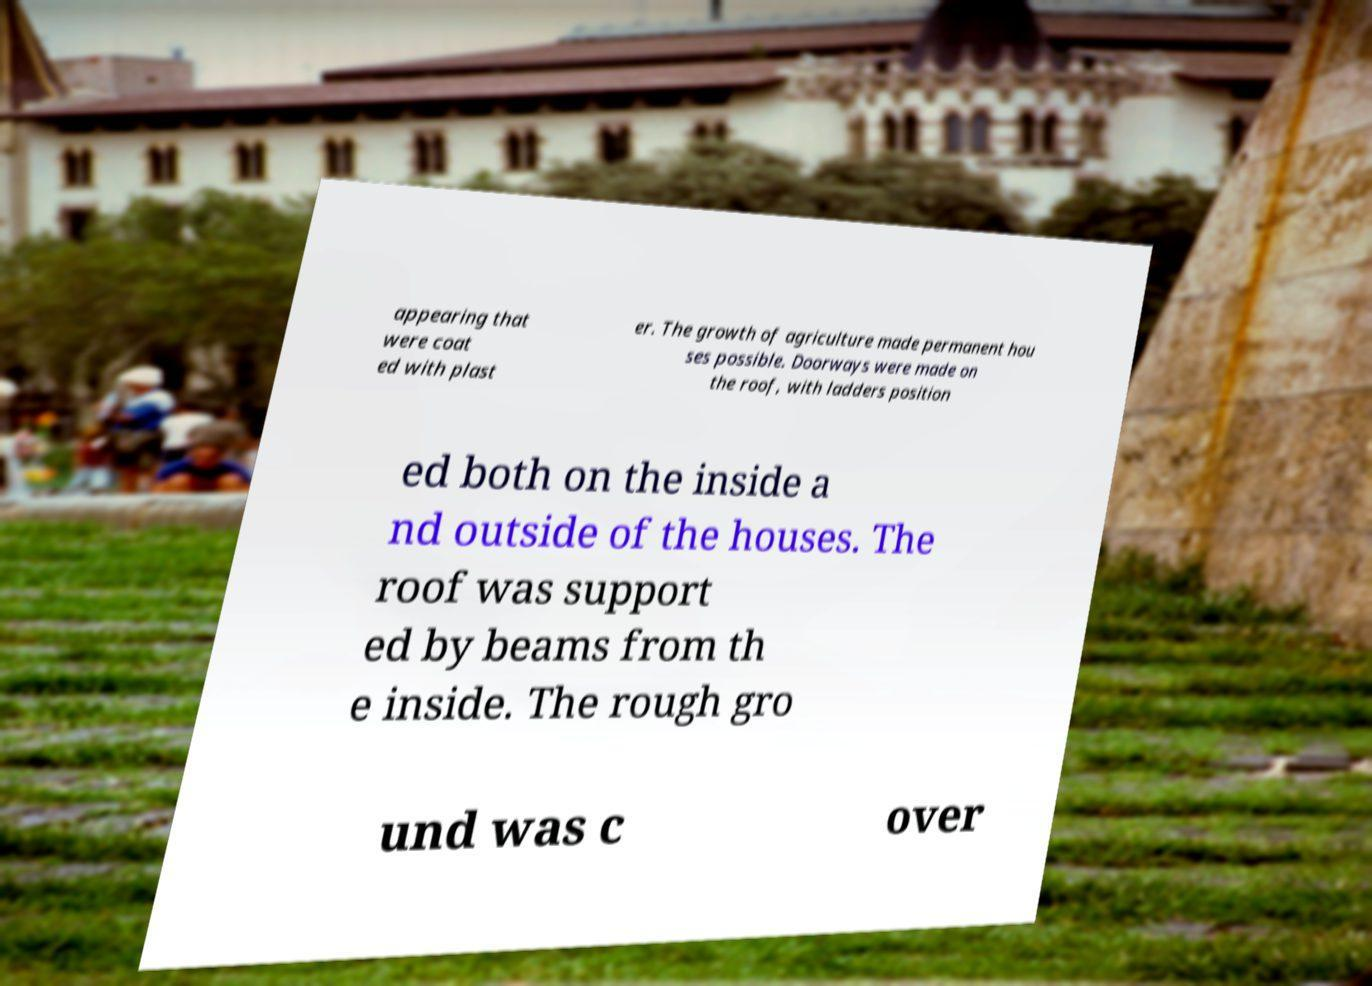What messages or text are displayed in this image? I need them in a readable, typed format. appearing that were coat ed with plast er. The growth of agriculture made permanent hou ses possible. Doorways were made on the roof, with ladders position ed both on the inside a nd outside of the houses. The roof was support ed by beams from th e inside. The rough gro und was c over 